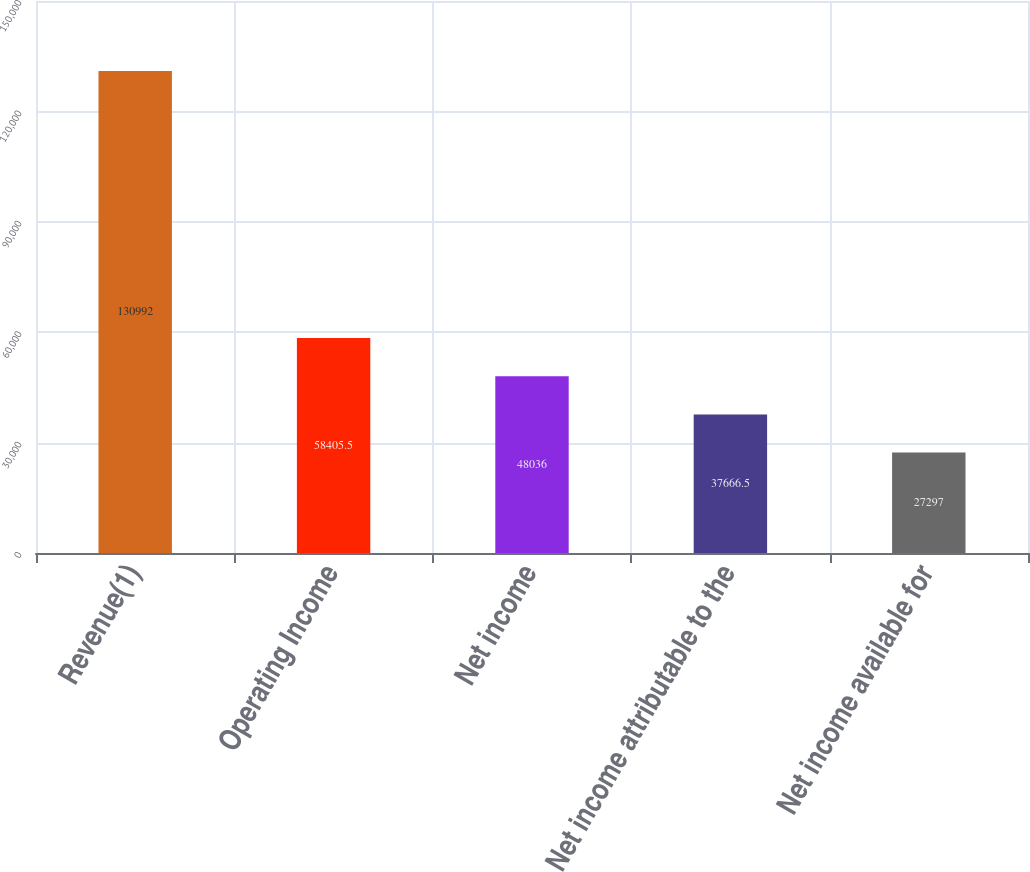<chart> <loc_0><loc_0><loc_500><loc_500><bar_chart><fcel>Revenue(1)<fcel>Operating Income<fcel>Net income<fcel>Net income attributable to the<fcel>Net income available for<nl><fcel>130992<fcel>58405.5<fcel>48036<fcel>37666.5<fcel>27297<nl></chart> 